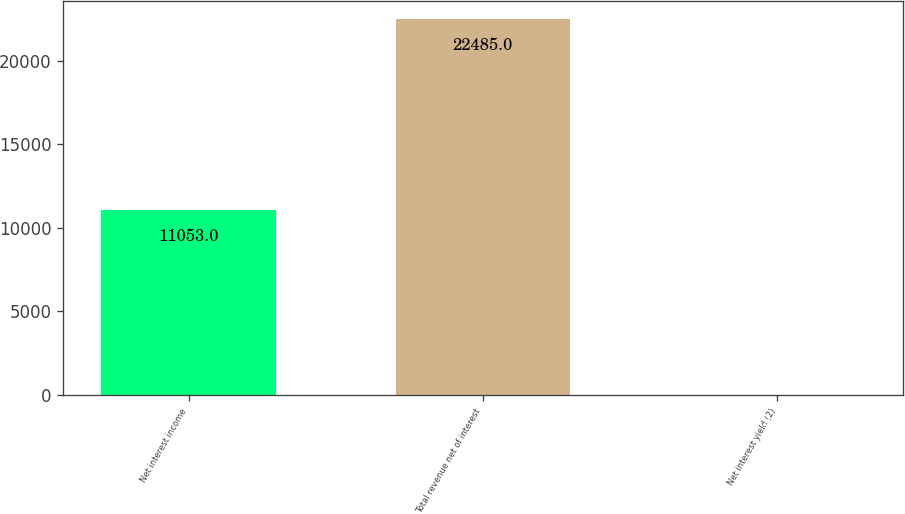<chart> <loc_0><loc_0><loc_500><loc_500><bar_chart><fcel>Net interest income<fcel>Total revenue net of interest<fcel>Net interest yield (2)<nl><fcel>11053<fcel>22485<fcel>2.51<nl></chart> 